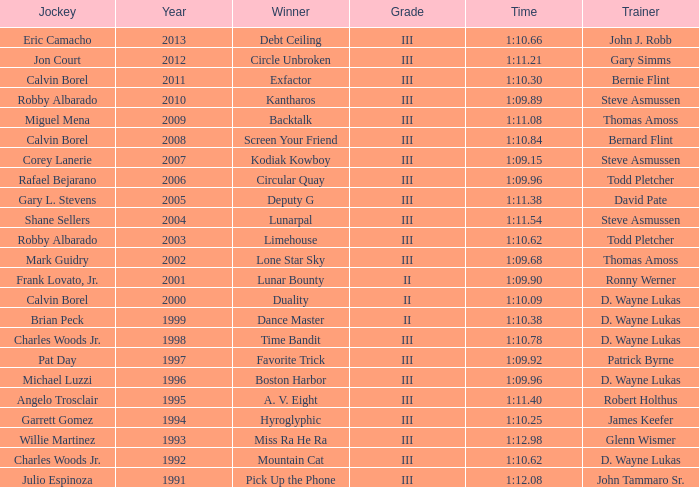Which trainer had a time of 1:10.09 with a year less than 2009? D. Wayne Lukas. 